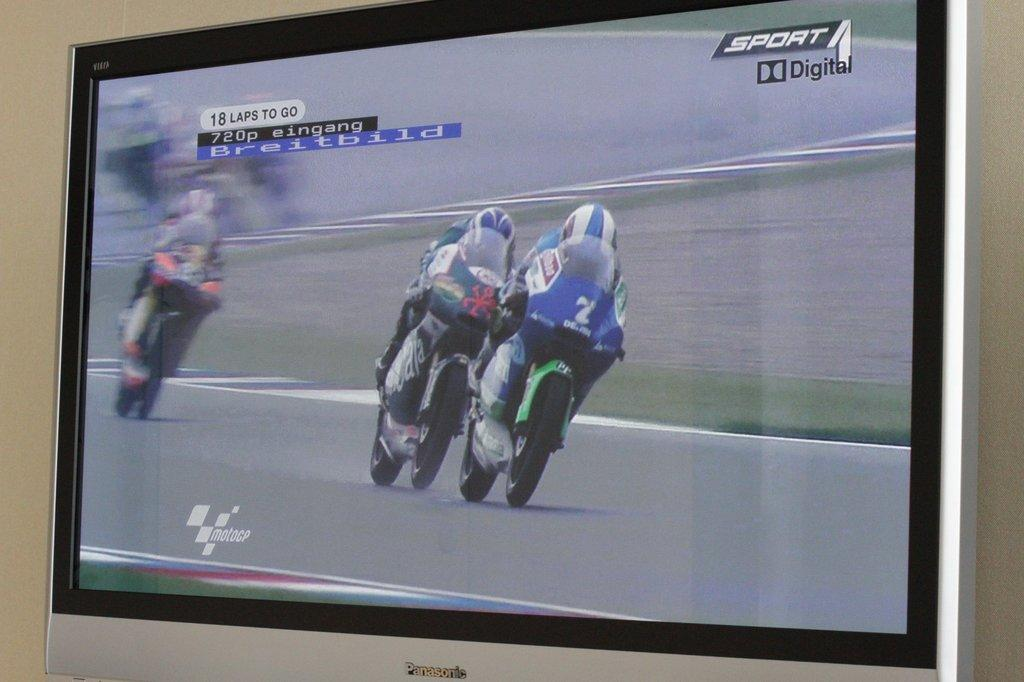<image>
Offer a succinct explanation of the picture presented. Screen showing two people racing on the SPORT DIGITAL channel. 